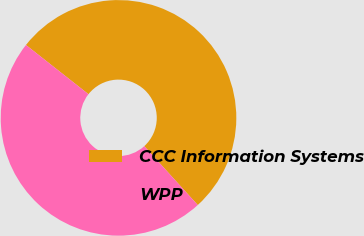Convert chart. <chart><loc_0><loc_0><loc_500><loc_500><pie_chart><fcel>CCC Information Systems<fcel>WPP<nl><fcel>52.64%<fcel>47.36%<nl></chart> 